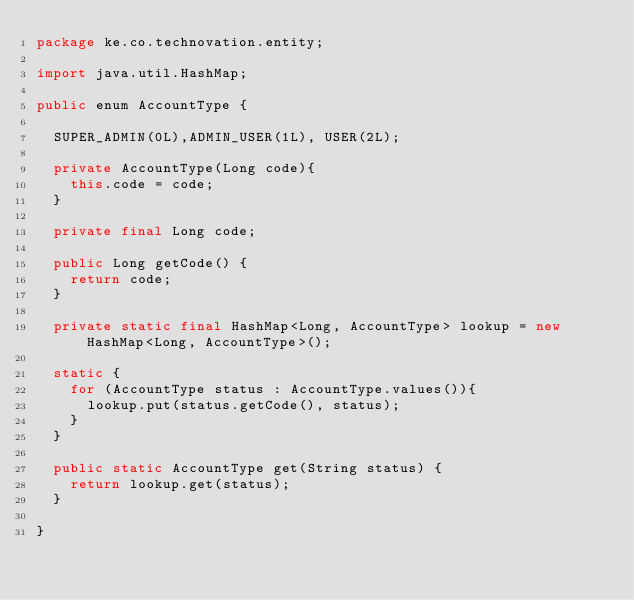Convert code to text. <code><loc_0><loc_0><loc_500><loc_500><_Java_>package ke.co.technovation.entity;

import java.util.HashMap;

public enum AccountType {
	
	SUPER_ADMIN(0L),ADMIN_USER(1L), USER(2L);
	
	private AccountType(Long code){
		this.code = code;
	}
	
	private final Long code;
	
	public Long getCode() {
		return code;
	}
	
	private static final HashMap<Long, AccountType> lookup = new HashMap<Long, AccountType>();
	
	static {
		for (AccountType status : AccountType.values()){
			lookup.put(status.getCode(), status);
		}
	}
	
	public static AccountType get(String status) {
		return lookup.get(status);
	}

}
</code> 